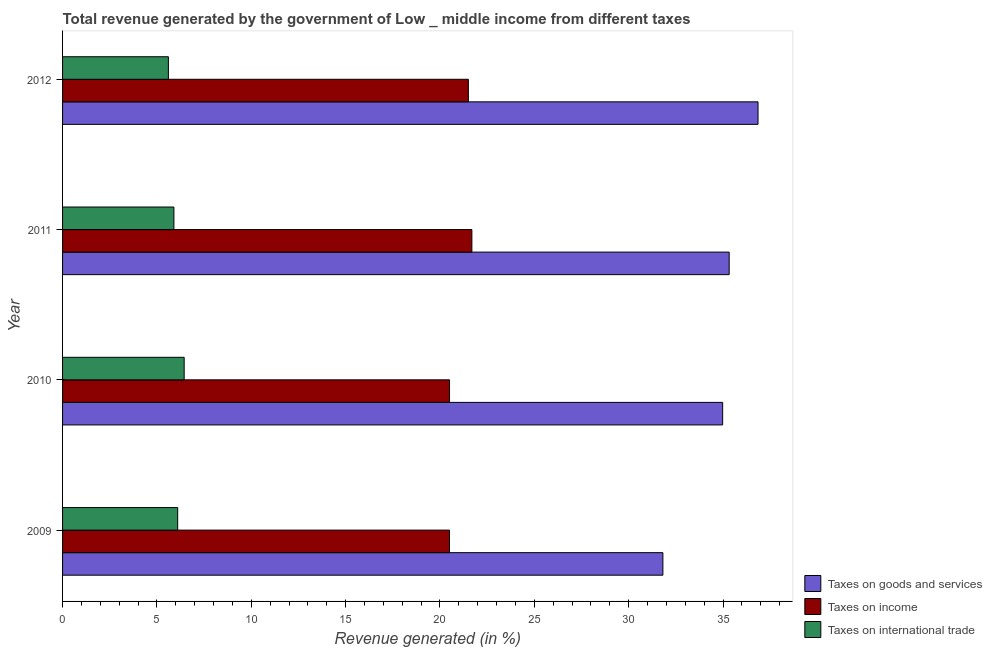How many different coloured bars are there?
Make the answer very short. 3. Are the number of bars per tick equal to the number of legend labels?
Your answer should be compact. Yes. What is the label of the 2nd group of bars from the top?
Offer a terse response. 2011. In how many cases, is the number of bars for a given year not equal to the number of legend labels?
Ensure brevity in your answer.  0. What is the percentage of revenue generated by tax on international trade in 2010?
Provide a short and direct response. 6.44. Across all years, what is the maximum percentage of revenue generated by taxes on income?
Offer a terse response. 21.69. Across all years, what is the minimum percentage of revenue generated by tax on international trade?
Your answer should be compact. 5.61. In which year was the percentage of revenue generated by tax on international trade maximum?
Provide a short and direct response. 2010. In which year was the percentage of revenue generated by taxes on goods and services minimum?
Make the answer very short. 2009. What is the total percentage of revenue generated by taxes on goods and services in the graph?
Provide a short and direct response. 138.97. What is the difference between the percentage of revenue generated by tax on international trade in 2011 and that in 2012?
Your answer should be very brief. 0.29. What is the difference between the percentage of revenue generated by taxes on income in 2009 and the percentage of revenue generated by tax on international trade in 2012?
Make the answer very short. 14.9. What is the average percentage of revenue generated by tax on international trade per year?
Provide a short and direct response. 6.01. In the year 2011, what is the difference between the percentage of revenue generated by taxes on income and percentage of revenue generated by taxes on goods and services?
Keep it short and to the point. -13.63. In how many years, is the percentage of revenue generated by tax on international trade greater than 18 %?
Your response must be concise. 0. What is the ratio of the percentage of revenue generated by tax on international trade in 2011 to that in 2012?
Provide a succinct answer. 1.05. Is the difference between the percentage of revenue generated by taxes on income in 2010 and 2011 greater than the difference between the percentage of revenue generated by taxes on goods and services in 2010 and 2011?
Ensure brevity in your answer.  No. What is the difference between the highest and the second highest percentage of revenue generated by taxes on income?
Offer a very short reply. 0.18. What is the difference between the highest and the lowest percentage of revenue generated by tax on international trade?
Keep it short and to the point. 0.84. In how many years, is the percentage of revenue generated by taxes on income greater than the average percentage of revenue generated by taxes on income taken over all years?
Your answer should be compact. 2. Is the sum of the percentage of revenue generated by tax on international trade in 2010 and 2012 greater than the maximum percentage of revenue generated by taxes on goods and services across all years?
Provide a succinct answer. No. What does the 2nd bar from the top in 2009 represents?
Your response must be concise. Taxes on income. What does the 1st bar from the bottom in 2012 represents?
Provide a succinct answer. Taxes on goods and services. How many years are there in the graph?
Your answer should be very brief. 4. Are the values on the major ticks of X-axis written in scientific E-notation?
Make the answer very short. No. Does the graph contain any zero values?
Keep it short and to the point. No. How many legend labels are there?
Provide a succinct answer. 3. What is the title of the graph?
Provide a succinct answer. Total revenue generated by the government of Low _ middle income from different taxes. What is the label or title of the X-axis?
Your response must be concise. Revenue generated (in %). What is the Revenue generated (in %) of Taxes on goods and services in 2009?
Your answer should be compact. 31.81. What is the Revenue generated (in %) in Taxes on income in 2009?
Make the answer very short. 20.5. What is the Revenue generated (in %) of Taxes on international trade in 2009?
Provide a succinct answer. 6.1. What is the Revenue generated (in %) of Taxes on goods and services in 2010?
Your answer should be compact. 34.98. What is the Revenue generated (in %) of Taxes on income in 2010?
Your response must be concise. 20.51. What is the Revenue generated (in %) of Taxes on international trade in 2010?
Provide a succinct answer. 6.44. What is the Revenue generated (in %) in Taxes on goods and services in 2011?
Provide a short and direct response. 35.33. What is the Revenue generated (in %) in Taxes on income in 2011?
Ensure brevity in your answer.  21.69. What is the Revenue generated (in %) in Taxes on international trade in 2011?
Offer a very short reply. 5.9. What is the Revenue generated (in %) of Taxes on goods and services in 2012?
Provide a succinct answer. 36.85. What is the Revenue generated (in %) of Taxes on income in 2012?
Offer a very short reply. 21.5. What is the Revenue generated (in %) in Taxes on international trade in 2012?
Your answer should be compact. 5.61. Across all years, what is the maximum Revenue generated (in %) of Taxes on goods and services?
Keep it short and to the point. 36.85. Across all years, what is the maximum Revenue generated (in %) of Taxes on income?
Offer a terse response. 21.69. Across all years, what is the maximum Revenue generated (in %) of Taxes on international trade?
Provide a succinct answer. 6.44. Across all years, what is the minimum Revenue generated (in %) in Taxes on goods and services?
Offer a very short reply. 31.81. Across all years, what is the minimum Revenue generated (in %) in Taxes on income?
Ensure brevity in your answer.  20.5. Across all years, what is the minimum Revenue generated (in %) of Taxes on international trade?
Keep it short and to the point. 5.61. What is the total Revenue generated (in %) in Taxes on goods and services in the graph?
Your answer should be compact. 138.97. What is the total Revenue generated (in %) of Taxes on income in the graph?
Provide a succinct answer. 84.2. What is the total Revenue generated (in %) of Taxes on international trade in the graph?
Provide a succinct answer. 24.05. What is the difference between the Revenue generated (in %) in Taxes on goods and services in 2009 and that in 2010?
Provide a short and direct response. -3.17. What is the difference between the Revenue generated (in %) of Taxes on income in 2009 and that in 2010?
Make the answer very short. -0. What is the difference between the Revenue generated (in %) in Taxes on international trade in 2009 and that in 2010?
Provide a succinct answer. -0.34. What is the difference between the Revenue generated (in %) in Taxes on goods and services in 2009 and that in 2011?
Make the answer very short. -3.51. What is the difference between the Revenue generated (in %) in Taxes on income in 2009 and that in 2011?
Provide a succinct answer. -1.19. What is the difference between the Revenue generated (in %) of Taxes on international trade in 2009 and that in 2011?
Your response must be concise. 0.2. What is the difference between the Revenue generated (in %) in Taxes on goods and services in 2009 and that in 2012?
Provide a short and direct response. -5.04. What is the difference between the Revenue generated (in %) of Taxes on income in 2009 and that in 2012?
Ensure brevity in your answer.  -1. What is the difference between the Revenue generated (in %) in Taxes on international trade in 2009 and that in 2012?
Provide a succinct answer. 0.49. What is the difference between the Revenue generated (in %) in Taxes on goods and services in 2010 and that in 2011?
Ensure brevity in your answer.  -0.35. What is the difference between the Revenue generated (in %) in Taxes on income in 2010 and that in 2011?
Your answer should be compact. -1.18. What is the difference between the Revenue generated (in %) of Taxes on international trade in 2010 and that in 2011?
Keep it short and to the point. 0.54. What is the difference between the Revenue generated (in %) in Taxes on goods and services in 2010 and that in 2012?
Your answer should be compact. -1.87. What is the difference between the Revenue generated (in %) in Taxes on income in 2010 and that in 2012?
Provide a succinct answer. -1. What is the difference between the Revenue generated (in %) of Taxes on international trade in 2010 and that in 2012?
Provide a succinct answer. 0.84. What is the difference between the Revenue generated (in %) of Taxes on goods and services in 2011 and that in 2012?
Keep it short and to the point. -1.53. What is the difference between the Revenue generated (in %) in Taxes on income in 2011 and that in 2012?
Give a very brief answer. 0.19. What is the difference between the Revenue generated (in %) in Taxes on international trade in 2011 and that in 2012?
Your answer should be compact. 0.29. What is the difference between the Revenue generated (in %) of Taxes on goods and services in 2009 and the Revenue generated (in %) of Taxes on income in 2010?
Offer a terse response. 11.31. What is the difference between the Revenue generated (in %) in Taxes on goods and services in 2009 and the Revenue generated (in %) in Taxes on international trade in 2010?
Make the answer very short. 25.37. What is the difference between the Revenue generated (in %) of Taxes on income in 2009 and the Revenue generated (in %) of Taxes on international trade in 2010?
Ensure brevity in your answer.  14.06. What is the difference between the Revenue generated (in %) in Taxes on goods and services in 2009 and the Revenue generated (in %) in Taxes on income in 2011?
Provide a succinct answer. 10.12. What is the difference between the Revenue generated (in %) of Taxes on goods and services in 2009 and the Revenue generated (in %) of Taxes on international trade in 2011?
Provide a short and direct response. 25.91. What is the difference between the Revenue generated (in %) in Taxes on income in 2009 and the Revenue generated (in %) in Taxes on international trade in 2011?
Keep it short and to the point. 14.6. What is the difference between the Revenue generated (in %) in Taxes on goods and services in 2009 and the Revenue generated (in %) in Taxes on income in 2012?
Ensure brevity in your answer.  10.31. What is the difference between the Revenue generated (in %) of Taxes on goods and services in 2009 and the Revenue generated (in %) of Taxes on international trade in 2012?
Provide a short and direct response. 26.2. What is the difference between the Revenue generated (in %) in Taxes on income in 2009 and the Revenue generated (in %) in Taxes on international trade in 2012?
Offer a terse response. 14.9. What is the difference between the Revenue generated (in %) of Taxes on goods and services in 2010 and the Revenue generated (in %) of Taxes on income in 2011?
Keep it short and to the point. 13.29. What is the difference between the Revenue generated (in %) in Taxes on goods and services in 2010 and the Revenue generated (in %) in Taxes on international trade in 2011?
Offer a very short reply. 29.08. What is the difference between the Revenue generated (in %) of Taxes on income in 2010 and the Revenue generated (in %) of Taxes on international trade in 2011?
Offer a terse response. 14.61. What is the difference between the Revenue generated (in %) in Taxes on goods and services in 2010 and the Revenue generated (in %) in Taxes on income in 2012?
Offer a terse response. 13.48. What is the difference between the Revenue generated (in %) of Taxes on goods and services in 2010 and the Revenue generated (in %) of Taxes on international trade in 2012?
Make the answer very short. 29.37. What is the difference between the Revenue generated (in %) of Taxes on income in 2010 and the Revenue generated (in %) of Taxes on international trade in 2012?
Offer a very short reply. 14.9. What is the difference between the Revenue generated (in %) in Taxes on goods and services in 2011 and the Revenue generated (in %) in Taxes on income in 2012?
Your answer should be very brief. 13.82. What is the difference between the Revenue generated (in %) in Taxes on goods and services in 2011 and the Revenue generated (in %) in Taxes on international trade in 2012?
Ensure brevity in your answer.  29.72. What is the difference between the Revenue generated (in %) of Taxes on income in 2011 and the Revenue generated (in %) of Taxes on international trade in 2012?
Give a very brief answer. 16.08. What is the average Revenue generated (in %) in Taxes on goods and services per year?
Give a very brief answer. 34.74. What is the average Revenue generated (in %) in Taxes on income per year?
Ensure brevity in your answer.  21.05. What is the average Revenue generated (in %) of Taxes on international trade per year?
Your response must be concise. 6.01. In the year 2009, what is the difference between the Revenue generated (in %) in Taxes on goods and services and Revenue generated (in %) in Taxes on income?
Provide a short and direct response. 11.31. In the year 2009, what is the difference between the Revenue generated (in %) in Taxes on goods and services and Revenue generated (in %) in Taxes on international trade?
Provide a short and direct response. 25.71. In the year 2009, what is the difference between the Revenue generated (in %) in Taxes on income and Revenue generated (in %) in Taxes on international trade?
Your answer should be compact. 14.4. In the year 2010, what is the difference between the Revenue generated (in %) in Taxes on goods and services and Revenue generated (in %) in Taxes on income?
Offer a terse response. 14.47. In the year 2010, what is the difference between the Revenue generated (in %) in Taxes on goods and services and Revenue generated (in %) in Taxes on international trade?
Provide a short and direct response. 28.54. In the year 2010, what is the difference between the Revenue generated (in %) in Taxes on income and Revenue generated (in %) in Taxes on international trade?
Offer a terse response. 14.06. In the year 2011, what is the difference between the Revenue generated (in %) in Taxes on goods and services and Revenue generated (in %) in Taxes on income?
Offer a very short reply. 13.64. In the year 2011, what is the difference between the Revenue generated (in %) of Taxes on goods and services and Revenue generated (in %) of Taxes on international trade?
Offer a terse response. 29.43. In the year 2011, what is the difference between the Revenue generated (in %) in Taxes on income and Revenue generated (in %) in Taxes on international trade?
Provide a short and direct response. 15.79. In the year 2012, what is the difference between the Revenue generated (in %) in Taxes on goods and services and Revenue generated (in %) in Taxes on income?
Offer a very short reply. 15.35. In the year 2012, what is the difference between the Revenue generated (in %) of Taxes on goods and services and Revenue generated (in %) of Taxes on international trade?
Offer a very short reply. 31.25. In the year 2012, what is the difference between the Revenue generated (in %) of Taxes on income and Revenue generated (in %) of Taxes on international trade?
Ensure brevity in your answer.  15.9. What is the ratio of the Revenue generated (in %) in Taxes on goods and services in 2009 to that in 2010?
Your answer should be very brief. 0.91. What is the ratio of the Revenue generated (in %) of Taxes on income in 2009 to that in 2010?
Make the answer very short. 1. What is the ratio of the Revenue generated (in %) of Taxes on international trade in 2009 to that in 2010?
Your answer should be compact. 0.95. What is the ratio of the Revenue generated (in %) in Taxes on goods and services in 2009 to that in 2011?
Ensure brevity in your answer.  0.9. What is the ratio of the Revenue generated (in %) in Taxes on income in 2009 to that in 2011?
Give a very brief answer. 0.95. What is the ratio of the Revenue generated (in %) of Taxes on international trade in 2009 to that in 2011?
Your response must be concise. 1.03. What is the ratio of the Revenue generated (in %) in Taxes on goods and services in 2009 to that in 2012?
Your response must be concise. 0.86. What is the ratio of the Revenue generated (in %) of Taxes on income in 2009 to that in 2012?
Your response must be concise. 0.95. What is the ratio of the Revenue generated (in %) of Taxes on international trade in 2009 to that in 2012?
Offer a very short reply. 1.09. What is the ratio of the Revenue generated (in %) of Taxes on goods and services in 2010 to that in 2011?
Provide a short and direct response. 0.99. What is the ratio of the Revenue generated (in %) of Taxes on income in 2010 to that in 2011?
Provide a succinct answer. 0.95. What is the ratio of the Revenue generated (in %) of Taxes on international trade in 2010 to that in 2011?
Give a very brief answer. 1.09. What is the ratio of the Revenue generated (in %) of Taxes on goods and services in 2010 to that in 2012?
Ensure brevity in your answer.  0.95. What is the ratio of the Revenue generated (in %) in Taxes on income in 2010 to that in 2012?
Ensure brevity in your answer.  0.95. What is the ratio of the Revenue generated (in %) in Taxes on international trade in 2010 to that in 2012?
Offer a very short reply. 1.15. What is the ratio of the Revenue generated (in %) in Taxes on goods and services in 2011 to that in 2012?
Provide a succinct answer. 0.96. What is the ratio of the Revenue generated (in %) of Taxes on income in 2011 to that in 2012?
Keep it short and to the point. 1.01. What is the ratio of the Revenue generated (in %) of Taxes on international trade in 2011 to that in 2012?
Your answer should be compact. 1.05. What is the difference between the highest and the second highest Revenue generated (in %) in Taxes on goods and services?
Offer a terse response. 1.53. What is the difference between the highest and the second highest Revenue generated (in %) in Taxes on income?
Ensure brevity in your answer.  0.19. What is the difference between the highest and the second highest Revenue generated (in %) in Taxes on international trade?
Provide a short and direct response. 0.34. What is the difference between the highest and the lowest Revenue generated (in %) of Taxes on goods and services?
Make the answer very short. 5.04. What is the difference between the highest and the lowest Revenue generated (in %) of Taxes on income?
Your answer should be compact. 1.19. What is the difference between the highest and the lowest Revenue generated (in %) in Taxes on international trade?
Your answer should be compact. 0.84. 